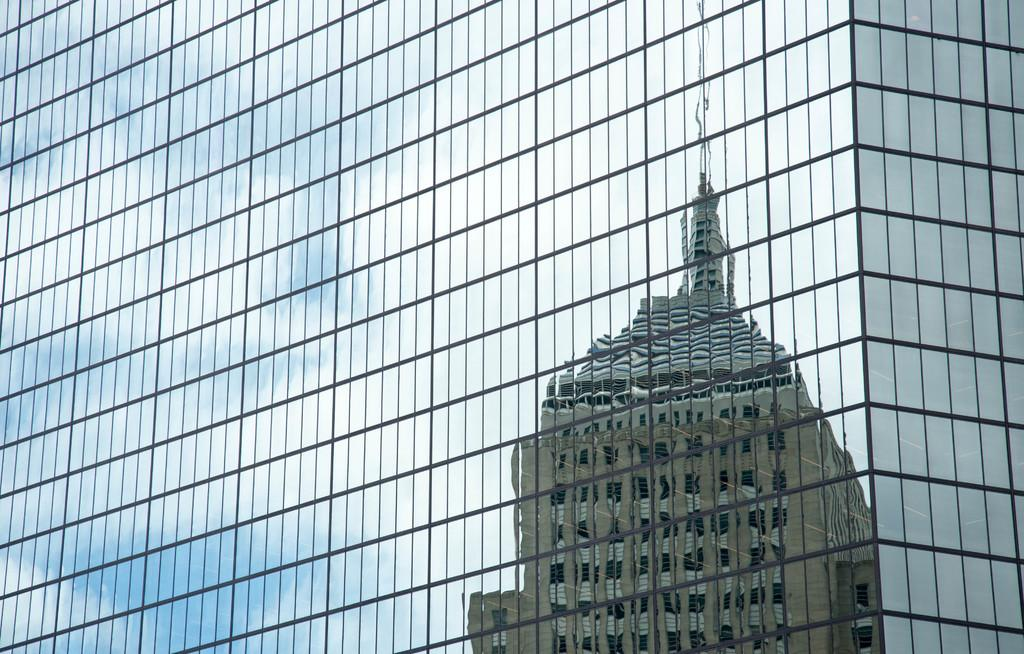What is the main structure visible in the image? There is a building in the image. What feature can be seen on the building? The building has glasses on it. What can be observed in the glasses? There is a reflection of another building on the glasses. What type of hose is connected to the building in the image? There is no hose connected to the building in the image. Can you see any pencils lying around near the building? There are no pencils visible in the image. 